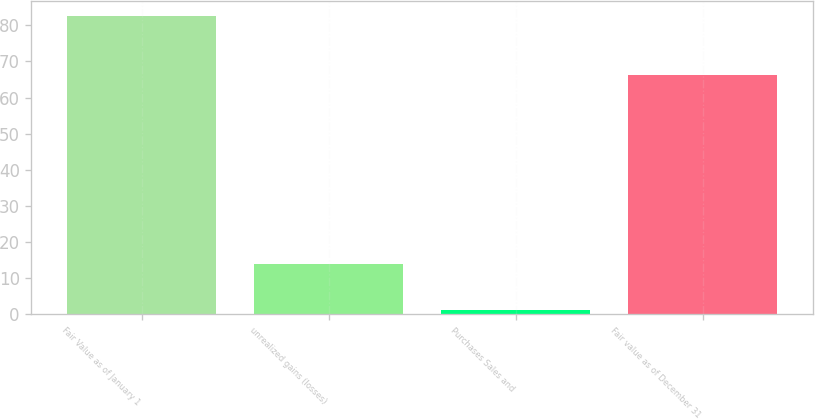<chart> <loc_0><loc_0><loc_500><loc_500><bar_chart><fcel>Fair Value as of January 1<fcel>unrealized gains (losses)<fcel>Purchases Sales and<fcel>Fair value as of December 31<nl><fcel>82.6<fcel>14<fcel>1.2<fcel>66.2<nl></chart> 